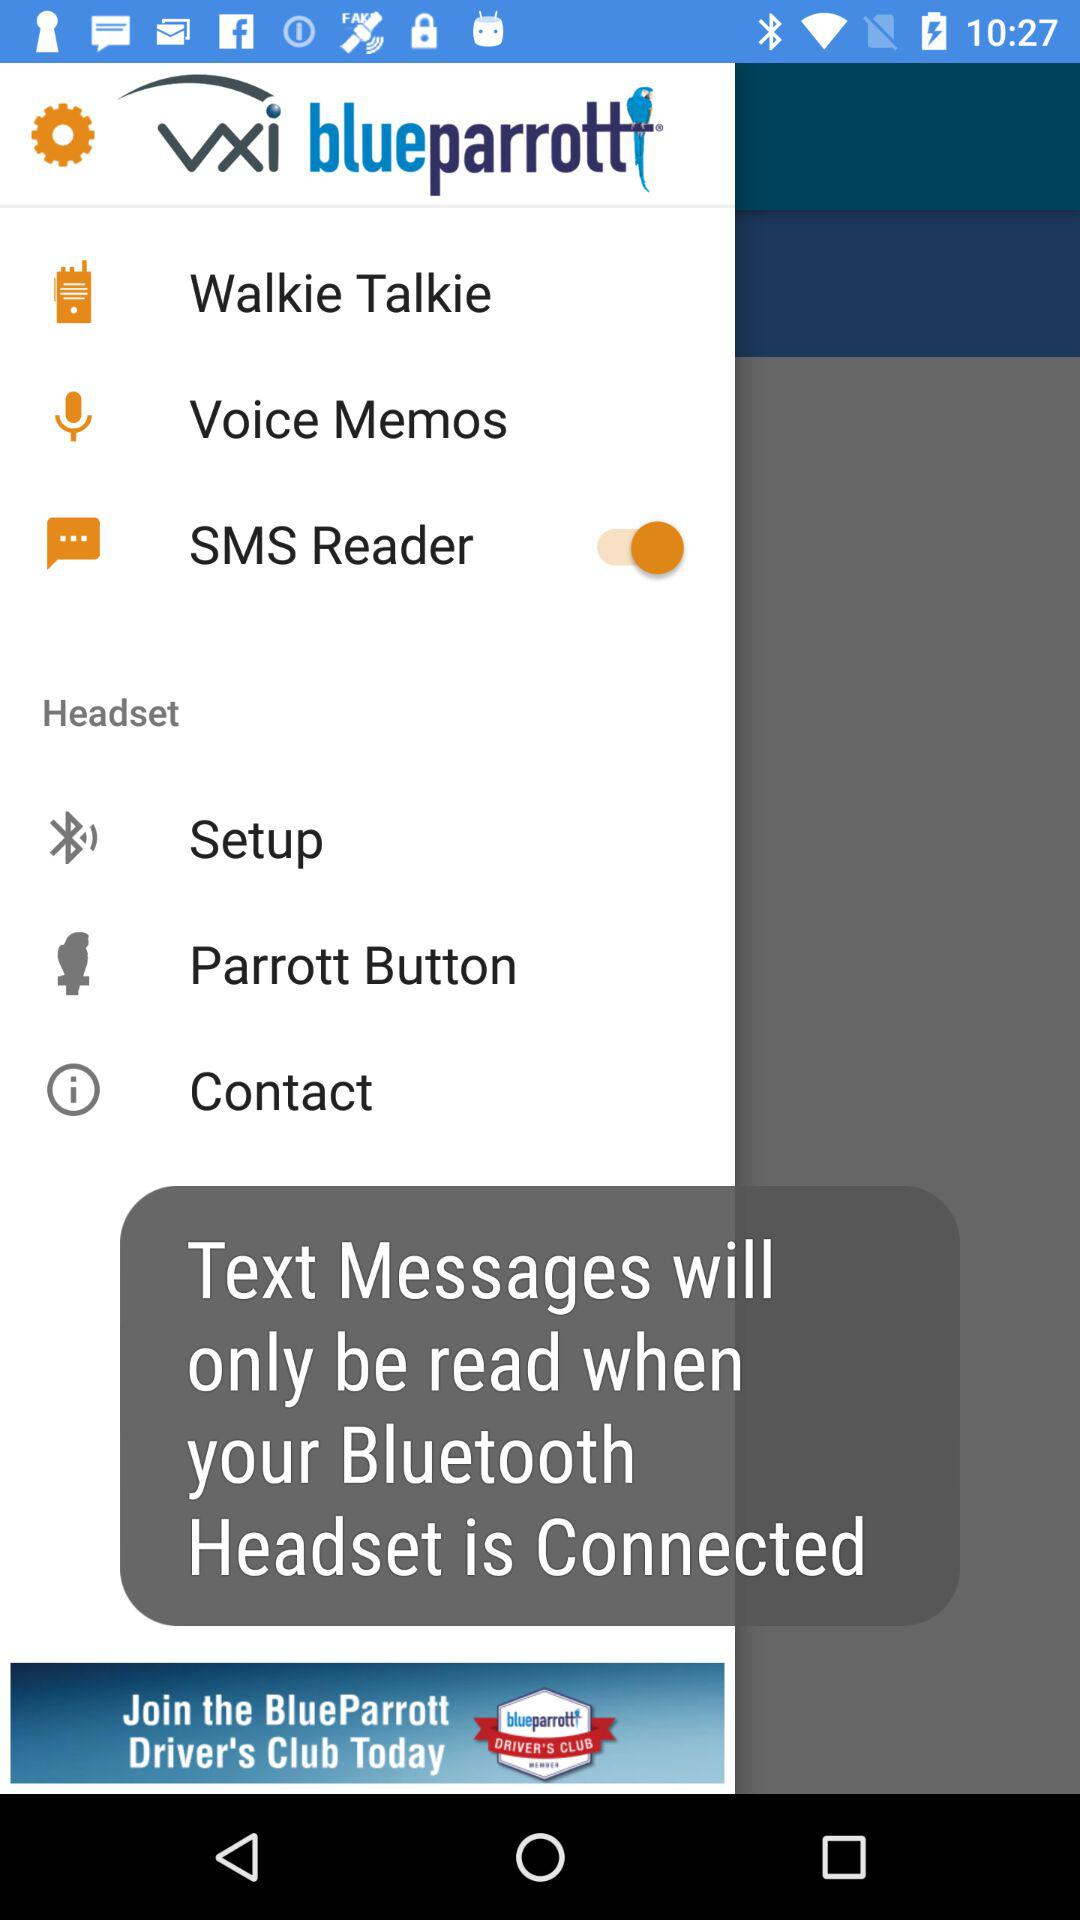What is the application name? The application name is "vxi blueparrott". 